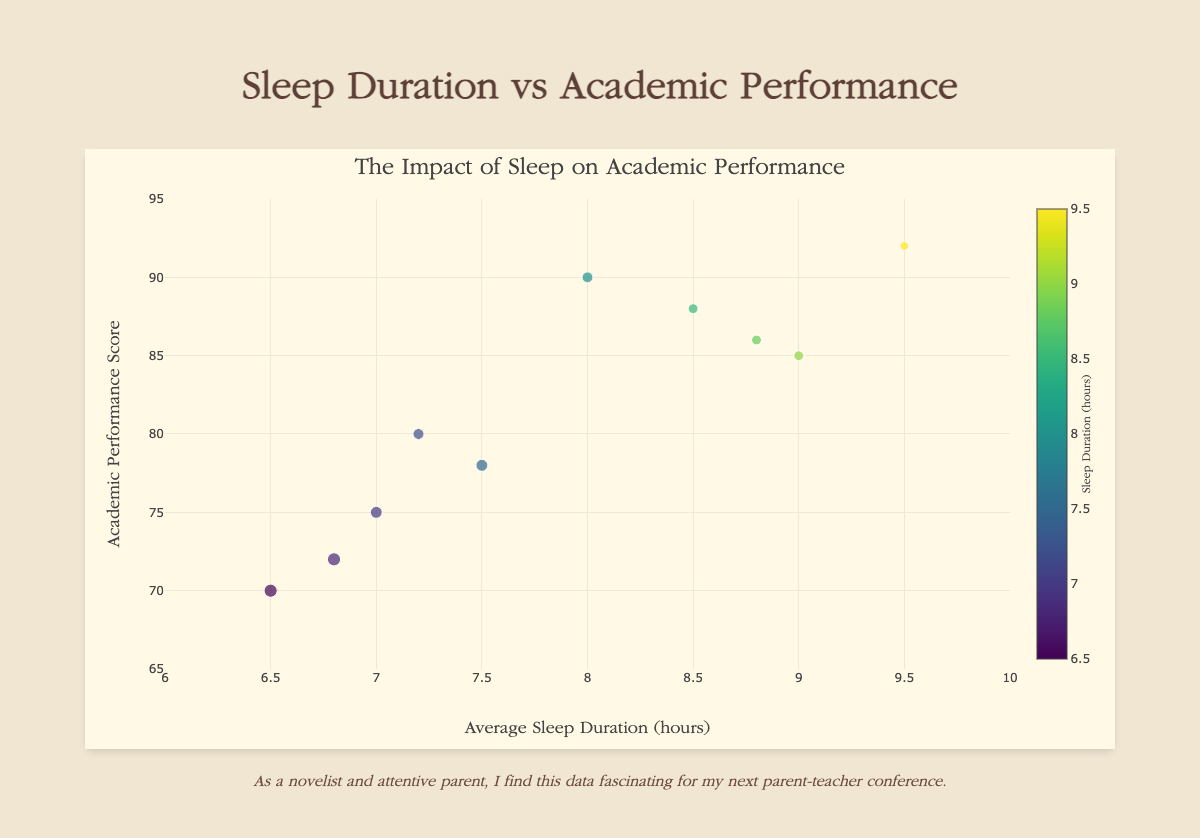What is the title of the chart? The title of the chart is displayed at the top and reads: "The Impact of Sleep on Academic Performance"
Answer: The Impact of Sleep on Academic Performance Which student has the highest academic performance score? From the chart, look at the y-axis values, the student with the highest score (92) is identified using their label when hovering over the topmost bubble. The student's name is shown as "Grace Moore"
Answer: Grace Moore What is the range of average sleep duration? By examining the x-axis, we see it starts at 6 and ends at 10, indicating the range from 6 to 10 hours of sleep
Answer: 6 to 10 hours How many students have an academic performance score of at least 85? Identify bubbles where the y-axis value is 85 or higher. There are 6 such students: "Alice Johnson", "Catherine Lee", "Emily Davis", "Grace Moore", "Isabella Anderson"
Answer: 6 Which student sleeps the most, and what is their academic performance score? Look for the largest x-axis value (9.5). The corresponding y-axis value when hovering displays "Grace Moore" with a score of 92
Answer: Grace Moore, 92 What is the sleep duration difference between Jack Thompson and Alice Johnson? Calculate the difference between their sleep durations: (9.0 - 6.8). The difference is 2.2 hours
Answer: 2.2 hours What color represents the lowest sleep duration and which student does it correspond to? Look at the color bar for the smallest value, a darker hue, and identify the smallest bubble. The corresponding student is "Daniel Brown" with a sleep duration of 6.5 hours
Answer: Daniel Brown Who has a better academic performance, Benjamin Smith or Emily Davis, and by how much? Refer to the y-axis values: Emily (88) and Benjamin (78). Subtract to find the difference: 88 - 78 = 10 points
Answer: Emily Davis by 10 points How many students have a sleep duration of more than 8 hours? Count bubbles where the x-axis value exceeds 8: "Alice Johnson", "Emily Davis", "Grace Moore", "Isabella Anderson",  and "Catherine Lee"
Answer: 5 What is the average academic performance score for students who sleep less than 7 hours? Identify the students: "Daniel Brown" (70) and "Jack Thompson" (72). Calculate the average: (70 + 72) / 2 = 71
Answer: 71 